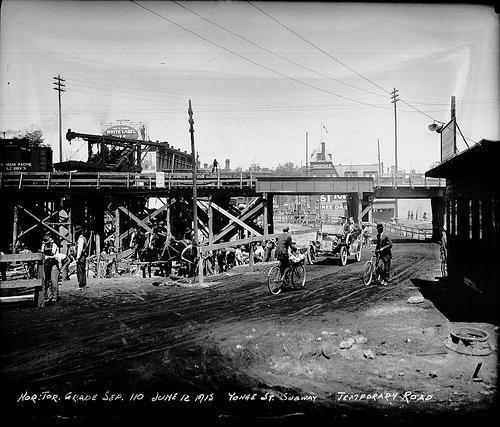How many horses can be seen in the photo?
Give a very brief answer. 2. 